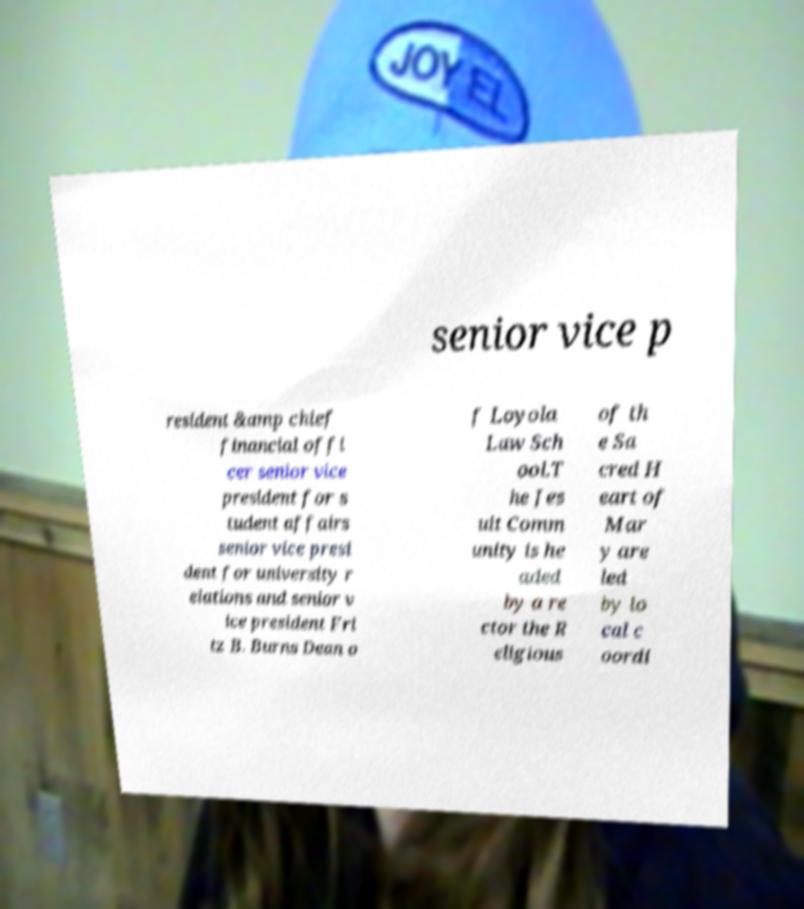Can you accurately transcribe the text from the provided image for me? senior vice p resident &amp chief financial offi cer senior vice president for s tudent affairs senior vice presi dent for university r elations and senior v ice president Fri tz B. Burns Dean o f Loyola Law Sch ool.T he Jes uit Comm unity is he aded by a re ctor the R eligious of th e Sa cred H eart of Mar y are led by lo cal c oordi 